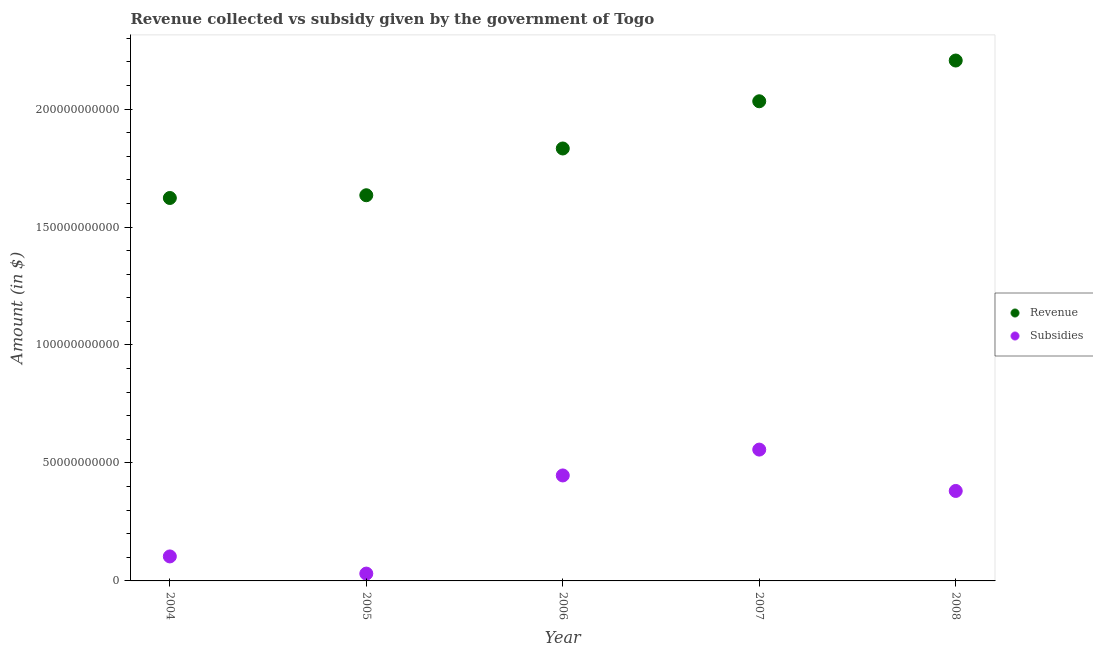What is the amount of subsidies given in 2005?
Your response must be concise. 3.11e+09. Across all years, what is the maximum amount of subsidies given?
Provide a short and direct response. 5.57e+1. Across all years, what is the minimum amount of revenue collected?
Give a very brief answer. 1.62e+11. In which year was the amount of subsidies given maximum?
Keep it short and to the point. 2007. In which year was the amount of subsidies given minimum?
Provide a succinct answer. 2005. What is the total amount of revenue collected in the graph?
Your answer should be compact. 9.33e+11. What is the difference between the amount of subsidies given in 2004 and that in 2008?
Your answer should be very brief. -2.78e+1. What is the difference between the amount of subsidies given in 2007 and the amount of revenue collected in 2005?
Keep it short and to the point. -1.08e+11. What is the average amount of revenue collected per year?
Offer a terse response. 1.87e+11. In the year 2007, what is the difference between the amount of subsidies given and amount of revenue collected?
Make the answer very short. -1.48e+11. What is the ratio of the amount of subsidies given in 2006 to that in 2008?
Provide a short and direct response. 1.17. Is the amount of subsidies given in 2005 less than that in 2008?
Make the answer very short. Yes. Is the difference between the amount of subsidies given in 2005 and 2008 greater than the difference between the amount of revenue collected in 2005 and 2008?
Your response must be concise. Yes. What is the difference between the highest and the second highest amount of revenue collected?
Ensure brevity in your answer.  1.73e+1. What is the difference between the highest and the lowest amount of subsidies given?
Offer a very short reply. 5.26e+1. In how many years, is the amount of revenue collected greater than the average amount of revenue collected taken over all years?
Ensure brevity in your answer.  2. Is the sum of the amount of revenue collected in 2006 and 2007 greater than the maximum amount of subsidies given across all years?
Provide a succinct answer. Yes. Does the amount of subsidies given monotonically increase over the years?
Offer a very short reply. No. Is the amount of subsidies given strictly greater than the amount of revenue collected over the years?
Your answer should be very brief. No. How many years are there in the graph?
Make the answer very short. 5. What is the difference between two consecutive major ticks on the Y-axis?
Offer a very short reply. 5.00e+1. Does the graph contain grids?
Offer a terse response. No. How many legend labels are there?
Offer a terse response. 2. What is the title of the graph?
Offer a terse response. Revenue collected vs subsidy given by the government of Togo. What is the label or title of the X-axis?
Your answer should be very brief. Year. What is the label or title of the Y-axis?
Your response must be concise. Amount (in $). What is the Amount (in $) in Revenue in 2004?
Give a very brief answer. 1.62e+11. What is the Amount (in $) in Subsidies in 2004?
Give a very brief answer. 1.04e+1. What is the Amount (in $) in Revenue in 2005?
Provide a short and direct response. 1.63e+11. What is the Amount (in $) of Subsidies in 2005?
Ensure brevity in your answer.  3.11e+09. What is the Amount (in $) of Revenue in 2006?
Your answer should be very brief. 1.83e+11. What is the Amount (in $) in Subsidies in 2006?
Ensure brevity in your answer.  4.47e+1. What is the Amount (in $) in Revenue in 2007?
Offer a terse response. 2.03e+11. What is the Amount (in $) of Subsidies in 2007?
Keep it short and to the point. 5.57e+1. What is the Amount (in $) of Revenue in 2008?
Keep it short and to the point. 2.21e+11. What is the Amount (in $) in Subsidies in 2008?
Give a very brief answer. 3.81e+1. Across all years, what is the maximum Amount (in $) in Revenue?
Ensure brevity in your answer.  2.21e+11. Across all years, what is the maximum Amount (in $) of Subsidies?
Make the answer very short. 5.57e+1. Across all years, what is the minimum Amount (in $) of Revenue?
Keep it short and to the point. 1.62e+11. Across all years, what is the minimum Amount (in $) in Subsidies?
Your answer should be very brief. 3.11e+09. What is the total Amount (in $) of Revenue in the graph?
Provide a short and direct response. 9.33e+11. What is the total Amount (in $) in Subsidies in the graph?
Give a very brief answer. 1.52e+11. What is the difference between the Amount (in $) of Revenue in 2004 and that in 2005?
Your answer should be compact. -1.16e+09. What is the difference between the Amount (in $) of Subsidies in 2004 and that in 2005?
Keep it short and to the point. 7.28e+09. What is the difference between the Amount (in $) in Revenue in 2004 and that in 2006?
Your answer should be compact. -2.10e+1. What is the difference between the Amount (in $) of Subsidies in 2004 and that in 2006?
Give a very brief answer. -3.43e+1. What is the difference between the Amount (in $) of Revenue in 2004 and that in 2007?
Make the answer very short. -4.10e+1. What is the difference between the Amount (in $) of Subsidies in 2004 and that in 2007?
Offer a terse response. -4.53e+1. What is the difference between the Amount (in $) of Revenue in 2004 and that in 2008?
Make the answer very short. -5.83e+1. What is the difference between the Amount (in $) of Subsidies in 2004 and that in 2008?
Keep it short and to the point. -2.78e+1. What is the difference between the Amount (in $) in Revenue in 2005 and that in 2006?
Your answer should be compact. -1.98e+1. What is the difference between the Amount (in $) in Subsidies in 2005 and that in 2006?
Offer a very short reply. -4.16e+1. What is the difference between the Amount (in $) of Revenue in 2005 and that in 2007?
Keep it short and to the point. -3.98e+1. What is the difference between the Amount (in $) of Subsidies in 2005 and that in 2007?
Give a very brief answer. -5.26e+1. What is the difference between the Amount (in $) of Revenue in 2005 and that in 2008?
Offer a terse response. -5.71e+1. What is the difference between the Amount (in $) in Subsidies in 2005 and that in 2008?
Offer a terse response. -3.50e+1. What is the difference between the Amount (in $) of Revenue in 2006 and that in 2007?
Your answer should be very brief. -2.00e+1. What is the difference between the Amount (in $) of Subsidies in 2006 and that in 2007?
Offer a very short reply. -1.10e+1. What is the difference between the Amount (in $) in Revenue in 2006 and that in 2008?
Offer a very short reply. -3.73e+1. What is the difference between the Amount (in $) in Subsidies in 2006 and that in 2008?
Your response must be concise. 6.57e+09. What is the difference between the Amount (in $) in Revenue in 2007 and that in 2008?
Keep it short and to the point. -1.73e+1. What is the difference between the Amount (in $) of Subsidies in 2007 and that in 2008?
Offer a terse response. 1.75e+1. What is the difference between the Amount (in $) of Revenue in 2004 and the Amount (in $) of Subsidies in 2005?
Offer a very short reply. 1.59e+11. What is the difference between the Amount (in $) of Revenue in 2004 and the Amount (in $) of Subsidies in 2006?
Make the answer very short. 1.18e+11. What is the difference between the Amount (in $) in Revenue in 2004 and the Amount (in $) in Subsidies in 2007?
Keep it short and to the point. 1.07e+11. What is the difference between the Amount (in $) in Revenue in 2004 and the Amount (in $) in Subsidies in 2008?
Provide a succinct answer. 1.24e+11. What is the difference between the Amount (in $) in Revenue in 2005 and the Amount (in $) in Subsidies in 2006?
Your response must be concise. 1.19e+11. What is the difference between the Amount (in $) of Revenue in 2005 and the Amount (in $) of Subsidies in 2007?
Ensure brevity in your answer.  1.08e+11. What is the difference between the Amount (in $) in Revenue in 2005 and the Amount (in $) in Subsidies in 2008?
Provide a succinct answer. 1.25e+11. What is the difference between the Amount (in $) of Revenue in 2006 and the Amount (in $) of Subsidies in 2007?
Your answer should be compact. 1.28e+11. What is the difference between the Amount (in $) in Revenue in 2006 and the Amount (in $) in Subsidies in 2008?
Provide a succinct answer. 1.45e+11. What is the difference between the Amount (in $) in Revenue in 2007 and the Amount (in $) in Subsidies in 2008?
Offer a very short reply. 1.65e+11. What is the average Amount (in $) in Revenue per year?
Make the answer very short. 1.87e+11. What is the average Amount (in $) of Subsidies per year?
Provide a succinct answer. 3.04e+1. In the year 2004, what is the difference between the Amount (in $) of Revenue and Amount (in $) of Subsidies?
Make the answer very short. 1.52e+11. In the year 2005, what is the difference between the Amount (in $) of Revenue and Amount (in $) of Subsidies?
Provide a short and direct response. 1.60e+11. In the year 2006, what is the difference between the Amount (in $) of Revenue and Amount (in $) of Subsidies?
Make the answer very short. 1.39e+11. In the year 2007, what is the difference between the Amount (in $) of Revenue and Amount (in $) of Subsidies?
Offer a very short reply. 1.48e+11. In the year 2008, what is the difference between the Amount (in $) in Revenue and Amount (in $) in Subsidies?
Give a very brief answer. 1.82e+11. What is the ratio of the Amount (in $) in Revenue in 2004 to that in 2005?
Provide a short and direct response. 0.99. What is the ratio of the Amount (in $) of Subsidies in 2004 to that in 2005?
Make the answer very short. 3.34. What is the ratio of the Amount (in $) in Revenue in 2004 to that in 2006?
Offer a very short reply. 0.89. What is the ratio of the Amount (in $) in Subsidies in 2004 to that in 2006?
Your answer should be compact. 0.23. What is the ratio of the Amount (in $) of Revenue in 2004 to that in 2007?
Give a very brief answer. 0.8. What is the ratio of the Amount (in $) in Subsidies in 2004 to that in 2007?
Give a very brief answer. 0.19. What is the ratio of the Amount (in $) of Revenue in 2004 to that in 2008?
Make the answer very short. 0.74. What is the ratio of the Amount (in $) of Subsidies in 2004 to that in 2008?
Make the answer very short. 0.27. What is the ratio of the Amount (in $) of Revenue in 2005 to that in 2006?
Your answer should be compact. 0.89. What is the ratio of the Amount (in $) in Subsidies in 2005 to that in 2006?
Provide a succinct answer. 0.07. What is the ratio of the Amount (in $) of Revenue in 2005 to that in 2007?
Provide a succinct answer. 0.8. What is the ratio of the Amount (in $) in Subsidies in 2005 to that in 2007?
Provide a succinct answer. 0.06. What is the ratio of the Amount (in $) in Revenue in 2005 to that in 2008?
Give a very brief answer. 0.74. What is the ratio of the Amount (in $) of Subsidies in 2005 to that in 2008?
Offer a terse response. 0.08. What is the ratio of the Amount (in $) of Revenue in 2006 to that in 2007?
Give a very brief answer. 0.9. What is the ratio of the Amount (in $) of Subsidies in 2006 to that in 2007?
Keep it short and to the point. 0.8. What is the ratio of the Amount (in $) of Revenue in 2006 to that in 2008?
Your answer should be very brief. 0.83. What is the ratio of the Amount (in $) in Subsidies in 2006 to that in 2008?
Offer a terse response. 1.17. What is the ratio of the Amount (in $) in Revenue in 2007 to that in 2008?
Keep it short and to the point. 0.92. What is the ratio of the Amount (in $) of Subsidies in 2007 to that in 2008?
Offer a terse response. 1.46. What is the difference between the highest and the second highest Amount (in $) in Revenue?
Give a very brief answer. 1.73e+1. What is the difference between the highest and the second highest Amount (in $) of Subsidies?
Offer a very short reply. 1.10e+1. What is the difference between the highest and the lowest Amount (in $) in Revenue?
Provide a succinct answer. 5.83e+1. What is the difference between the highest and the lowest Amount (in $) of Subsidies?
Offer a very short reply. 5.26e+1. 